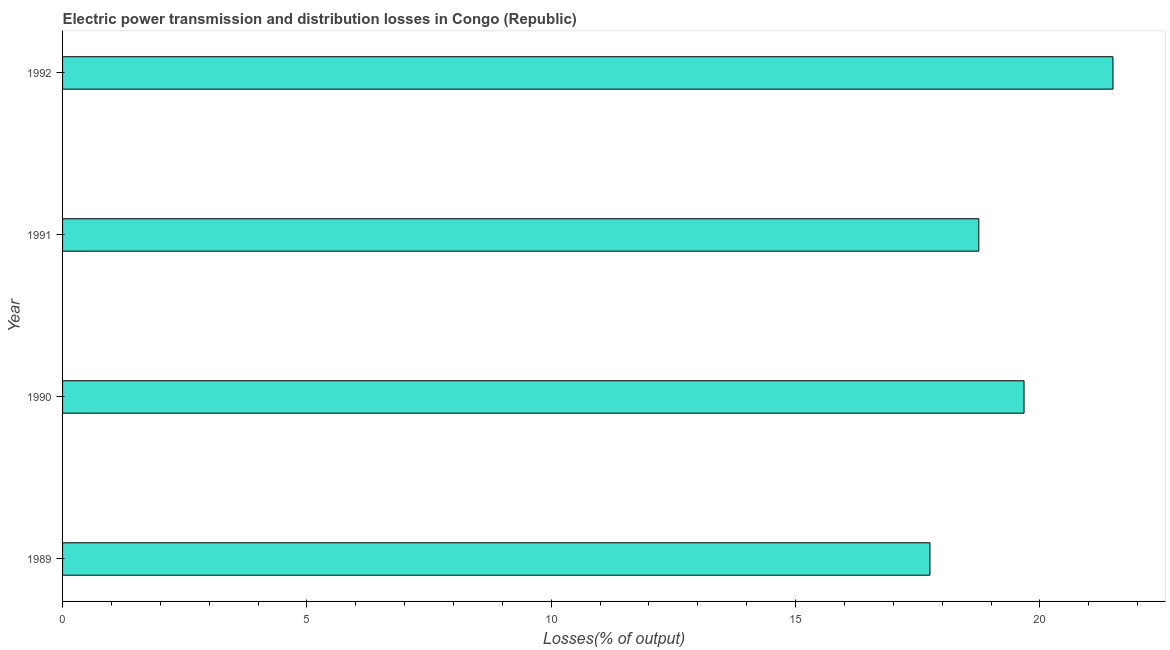Does the graph contain any zero values?
Ensure brevity in your answer.  No. Does the graph contain grids?
Offer a terse response. No. What is the title of the graph?
Offer a very short reply. Electric power transmission and distribution losses in Congo (Republic). What is the label or title of the X-axis?
Give a very brief answer. Losses(% of output). What is the electric power transmission and distribution losses in 1990?
Provide a short and direct response. 19.68. Across all years, what is the maximum electric power transmission and distribution losses?
Your response must be concise. 21.5. Across all years, what is the minimum electric power transmission and distribution losses?
Offer a very short reply. 17.75. In which year was the electric power transmission and distribution losses maximum?
Your answer should be very brief. 1992. What is the sum of the electric power transmission and distribution losses?
Keep it short and to the point. 77.67. What is the average electric power transmission and distribution losses per year?
Ensure brevity in your answer.  19.42. What is the median electric power transmission and distribution losses?
Your response must be concise. 19.21. In how many years, is the electric power transmission and distribution losses greater than 12 %?
Offer a very short reply. 4. What is the ratio of the electric power transmission and distribution losses in 1990 to that in 1992?
Offer a terse response. 0.92. Is the electric power transmission and distribution losses in 1989 less than that in 1990?
Make the answer very short. Yes. Is the difference between the electric power transmission and distribution losses in 1989 and 1990 greater than the difference between any two years?
Provide a succinct answer. No. What is the difference between the highest and the second highest electric power transmission and distribution losses?
Your response must be concise. 1.82. What is the difference between the highest and the lowest electric power transmission and distribution losses?
Keep it short and to the point. 3.75. In how many years, is the electric power transmission and distribution losses greater than the average electric power transmission and distribution losses taken over all years?
Your response must be concise. 2. How many bars are there?
Ensure brevity in your answer.  4. Are all the bars in the graph horizontal?
Your answer should be very brief. Yes. Are the values on the major ticks of X-axis written in scientific E-notation?
Your answer should be very brief. No. What is the Losses(% of output) of 1989?
Offer a very short reply. 17.75. What is the Losses(% of output) of 1990?
Make the answer very short. 19.68. What is the Losses(% of output) of 1991?
Ensure brevity in your answer.  18.75. What is the Losses(% of output) in 1992?
Give a very brief answer. 21.5. What is the difference between the Losses(% of output) in 1989 and 1990?
Make the answer very short. -1.93. What is the difference between the Losses(% of output) in 1989 and 1991?
Your response must be concise. -1. What is the difference between the Losses(% of output) in 1989 and 1992?
Provide a short and direct response. -3.75. What is the difference between the Losses(% of output) in 1990 and 1991?
Provide a succinct answer. 0.93. What is the difference between the Losses(% of output) in 1990 and 1992?
Your answer should be compact. -1.82. What is the difference between the Losses(% of output) in 1991 and 1992?
Provide a short and direct response. -2.75. What is the ratio of the Losses(% of output) in 1989 to that in 1990?
Your response must be concise. 0.9. What is the ratio of the Losses(% of output) in 1989 to that in 1991?
Your answer should be compact. 0.95. What is the ratio of the Losses(% of output) in 1989 to that in 1992?
Provide a short and direct response. 0.83. What is the ratio of the Losses(% of output) in 1990 to that in 1991?
Your answer should be very brief. 1.05. What is the ratio of the Losses(% of output) in 1990 to that in 1992?
Provide a succinct answer. 0.92. What is the ratio of the Losses(% of output) in 1991 to that in 1992?
Provide a succinct answer. 0.87. 